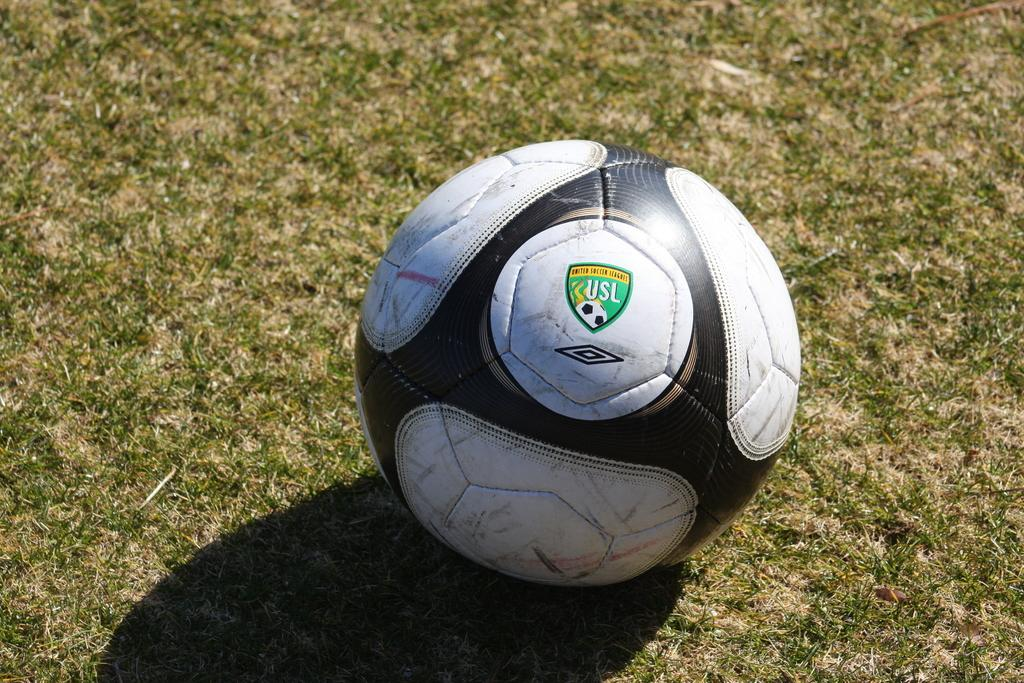What object is present in the image? There is a ball in the image. Where is the ball located? The ball is on the grass. What colors are visible on the ball? The ball is black and white in color. Where can you find a credit card in the image? There is no credit card present in the image; it only features a ball on the grass. 